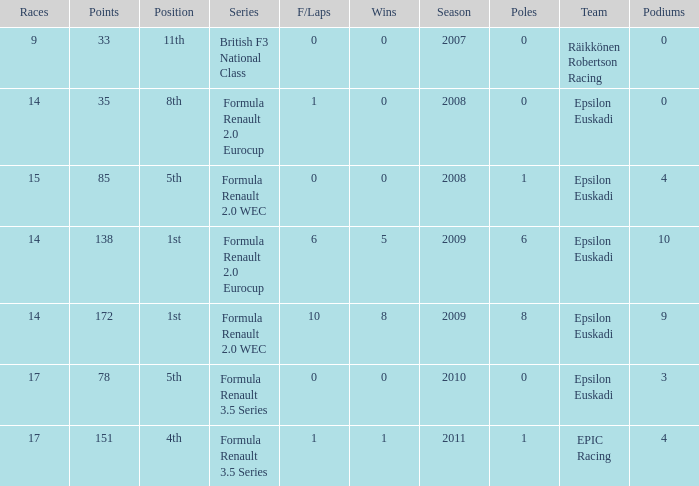I'm looking to parse the entire table for insights. Could you assist me with that? {'header': ['Races', 'Points', 'Position', 'Series', 'F/Laps', 'Wins', 'Season', 'Poles', 'Team', 'Podiums'], 'rows': [['9', '33', '11th', 'British F3 National Class', '0', '0', '2007', '0', 'Räikkönen Robertson Racing', '0'], ['14', '35', '8th', 'Formula Renault 2.0 Eurocup', '1', '0', '2008', '0', 'Epsilon Euskadi', '0'], ['15', '85', '5th', 'Formula Renault 2.0 WEC', '0', '0', '2008', '1', 'Epsilon Euskadi', '4'], ['14', '138', '1st', 'Formula Renault 2.0 Eurocup', '6', '5', '2009', '6', 'Epsilon Euskadi', '10'], ['14', '172', '1st', 'Formula Renault 2.0 WEC', '10', '8', '2009', '8', 'Epsilon Euskadi', '9'], ['17', '78', '5th', 'Formula Renault 3.5 Series', '0', '0', '2010', '0', 'Epsilon Euskadi', '3'], ['17', '151', '4th', 'Formula Renault 3.5 Series', '1', '1', '2011', '1', 'EPIC Racing', '4']]} What team was he on when he finished in 11th position? Räikkönen Robertson Racing. 